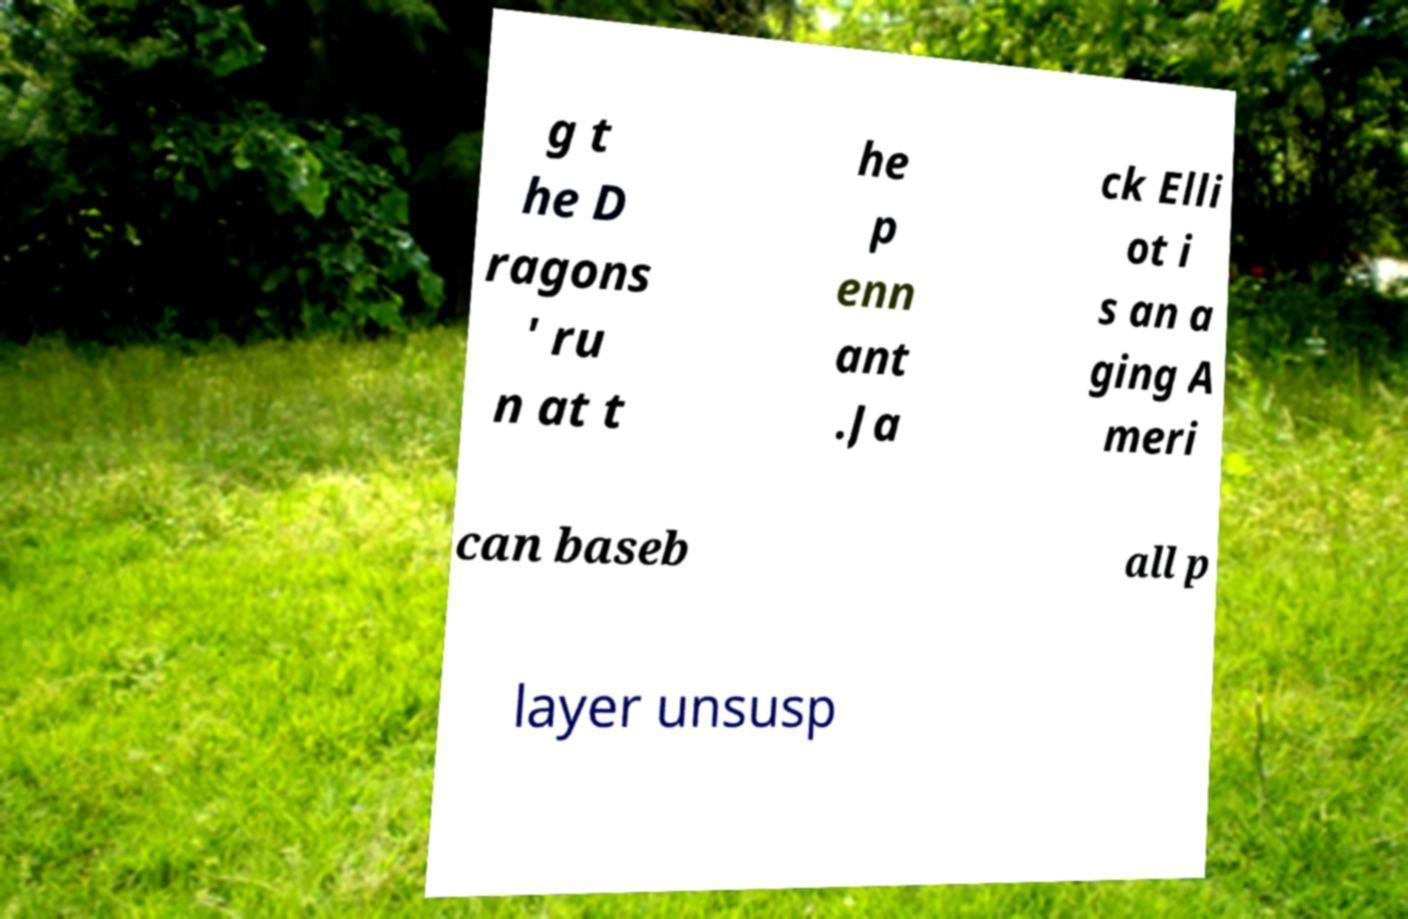There's text embedded in this image that I need extracted. Can you transcribe it verbatim? g t he D ragons ' ru n at t he p enn ant .Ja ck Elli ot i s an a ging A meri can baseb all p layer unsusp 